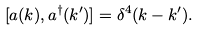Convert formula to latex. <formula><loc_0><loc_0><loc_500><loc_500>[ a ( k ) , a ^ { \dagger } ( k ^ { \prime } ) ] = \delta ^ { 4 } ( k - k ^ { \prime } ) .</formula> 